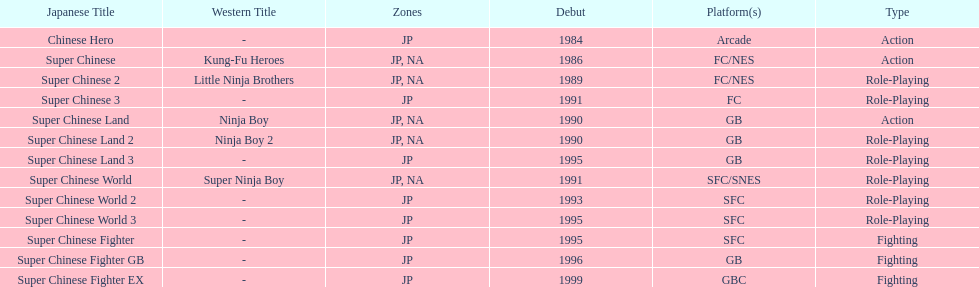Which platforms had the most titles released? GB. 